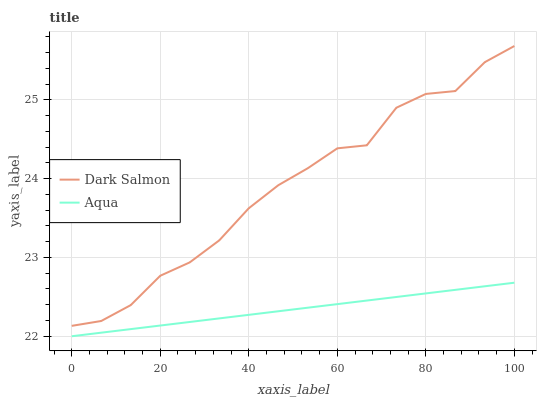Does Aqua have the minimum area under the curve?
Answer yes or no. Yes. Does Dark Salmon have the maximum area under the curve?
Answer yes or no. Yes. Does Dark Salmon have the minimum area under the curve?
Answer yes or no. No. Is Aqua the smoothest?
Answer yes or no. Yes. Is Dark Salmon the roughest?
Answer yes or no. Yes. Is Dark Salmon the smoothest?
Answer yes or no. No. Does Aqua have the lowest value?
Answer yes or no. Yes. Does Dark Salmon have the lowest value?
Answer yes or no. No. Does Dark Salmon have the highest value?
Answer yes or no. Yes. Is Aqua less than Dark Salmon?
Answer yes or no. Yes. Is Dark Salmon greater than Aqua?
Answer yes or no. Yes. Does Aqua intersect Dark Salmon?
Answer yes or no. No. 